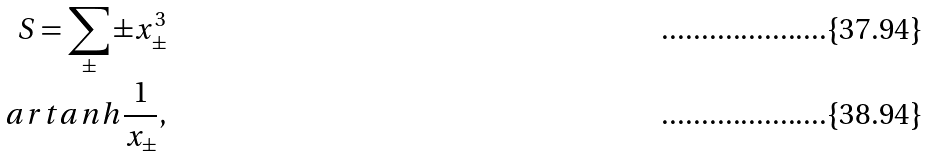<formula> <loc_0><loc_0><loc_500><loc_500>S = \sum _ { \pm } \pm x _ { \pm } ^ { 3 } \\ a r t a n h \frac { 1 } { x _ { \pm } } ,</formula> 